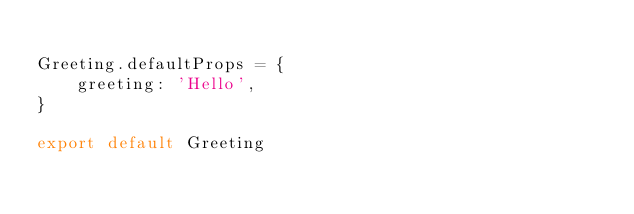Convert code to text. <code><loc_0><loc_0><loc_500><loc_500><_JavaScript_>
Greeting.defaultProps = {
    greeting: 'Hello',
}

export default Greeting</code> 